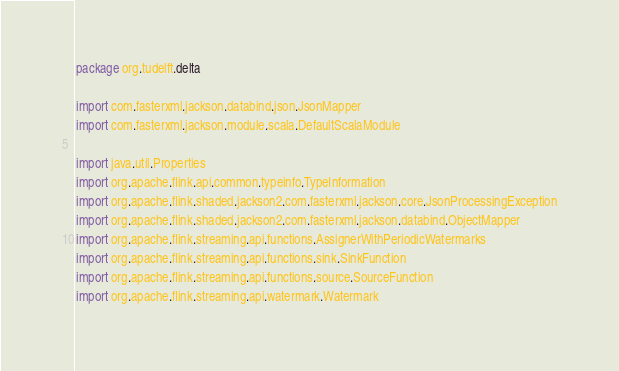<code> <loc_0><loc_0><loc_500><loc_500><_Scala_>package org.tudelft.delta

import com.fasterxml.jackson.databind.json.JsonMapper
import com.fasterxml.jackson.module.scala.DefaultScalaModule

import java.util.Properties
import org.apache.flink.api.common.typeinfo.TypeInformation
import org.apache.flink.shaded.jackson2.com.fasterxml.jackson.core.JsonProcessingException
import org.apache.flink.shaded.jackson2.com.fasterxml.jackson.databind.ObjectMapper
import org.apache.flink.streaming.api.functions.AssignerWithPeriodicWatermarks
import org.apache.flink.streaming.api.functions.sink.SinkFunction
import org.apache.flink.streaming.api.functions.source.SourceFunction
import org.apache.flink.streaming.api.watermark.Watermark</code> 